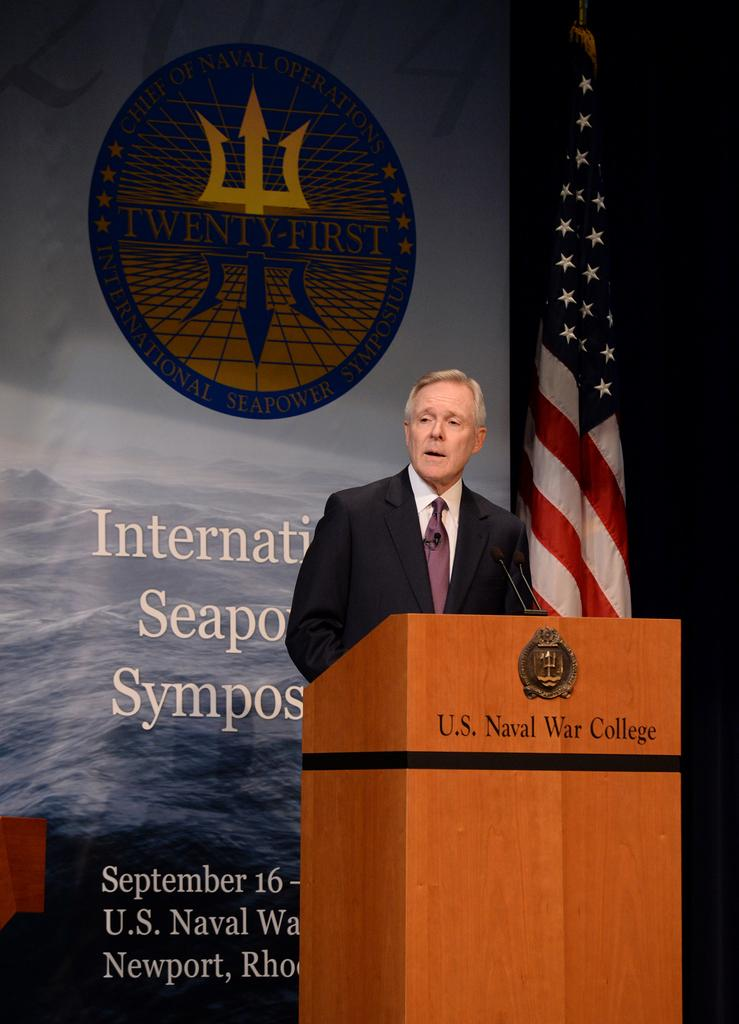Who is present in the image? There is a man in the image. What is the man wearing? The man is wearing a blazer and a tie. What is the man doing in the image? The man is standing at a podium. What objects can be seen near the man? There are microphones and a banner in the image. What other item is visible in the image? There is a flag in the image. What type of cloth is being used to make the machine in the image? There is no machine present in the image, and therefore no cloth being used to make it. 